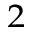Convert formula to latex. <formula><loc_0><loc_0><loc_500><loc_500>^ { 2 }</formula> 